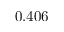Convert formula to latex. <formula><loc_0><loc_0><loc_500><loc_500>0 . 4 0 6</formula> 